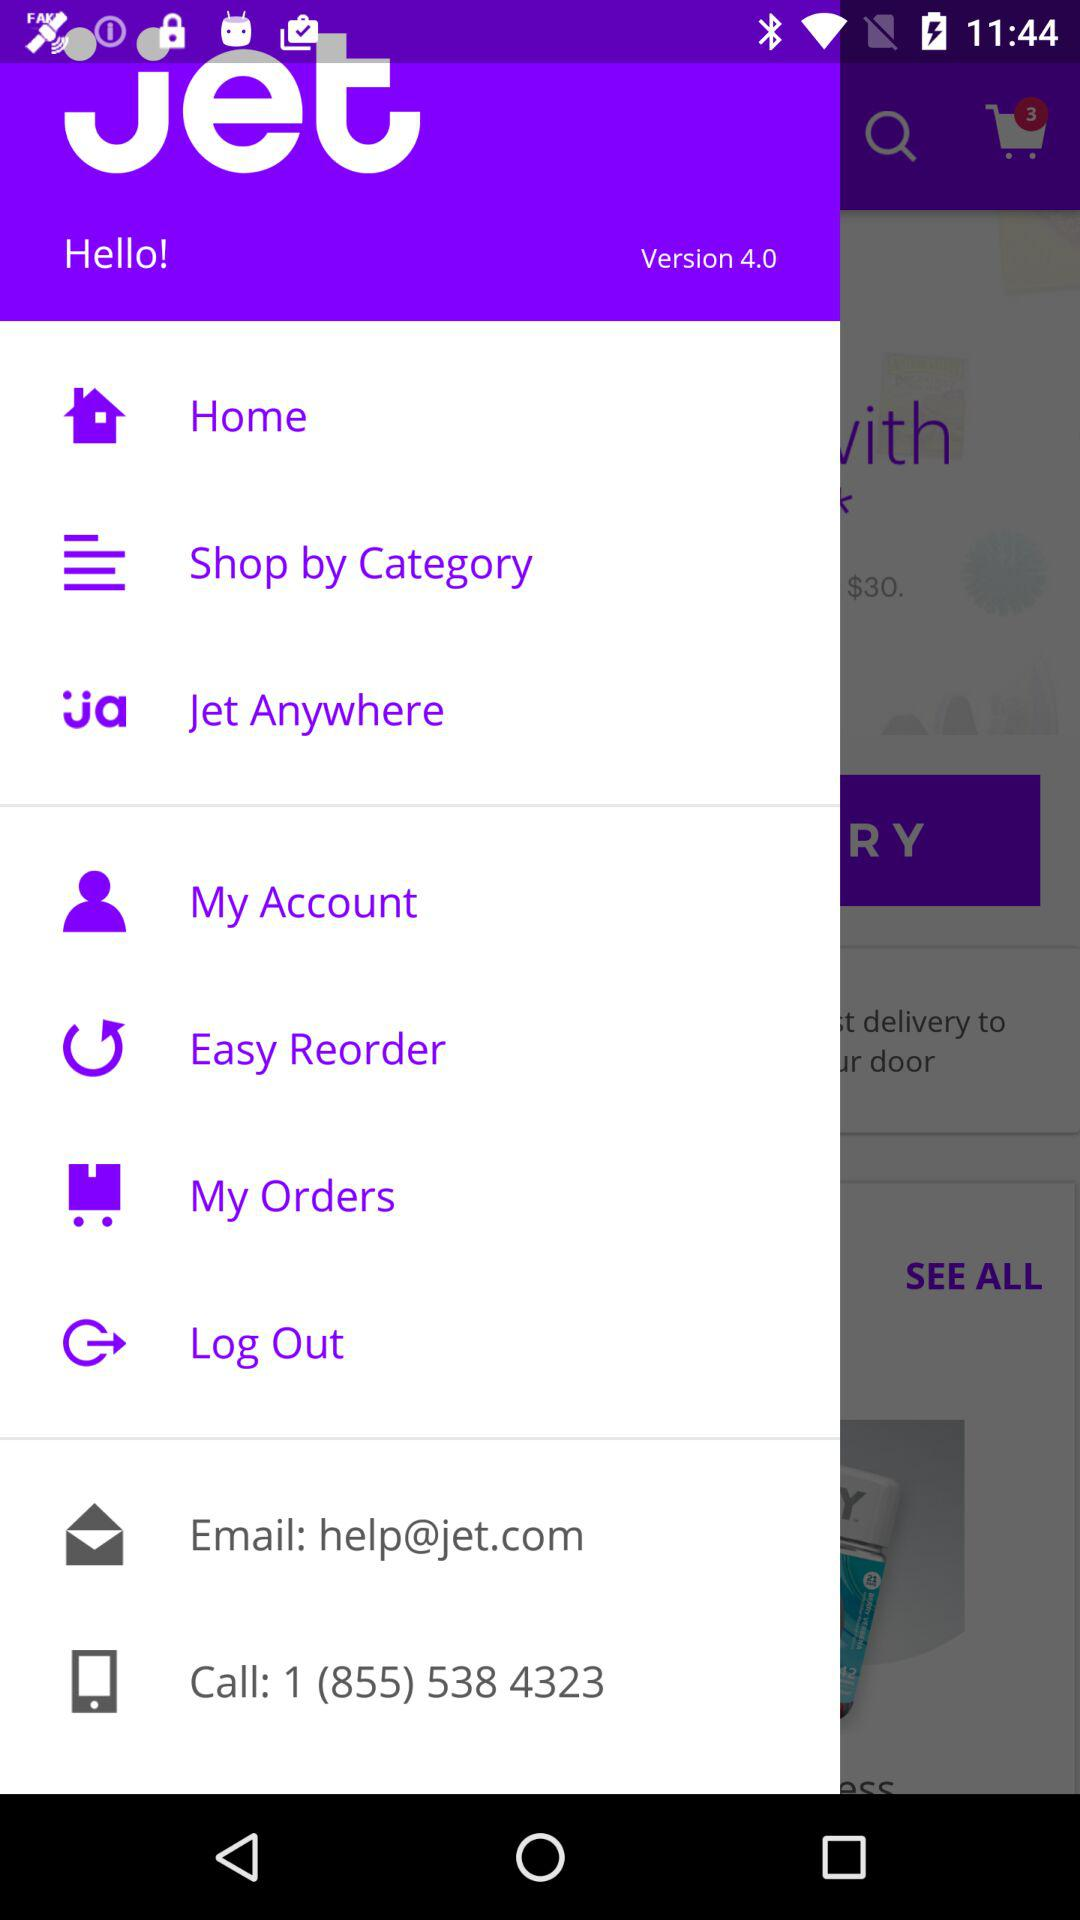What's the application mail address? The application mail address is help@jet.com. 